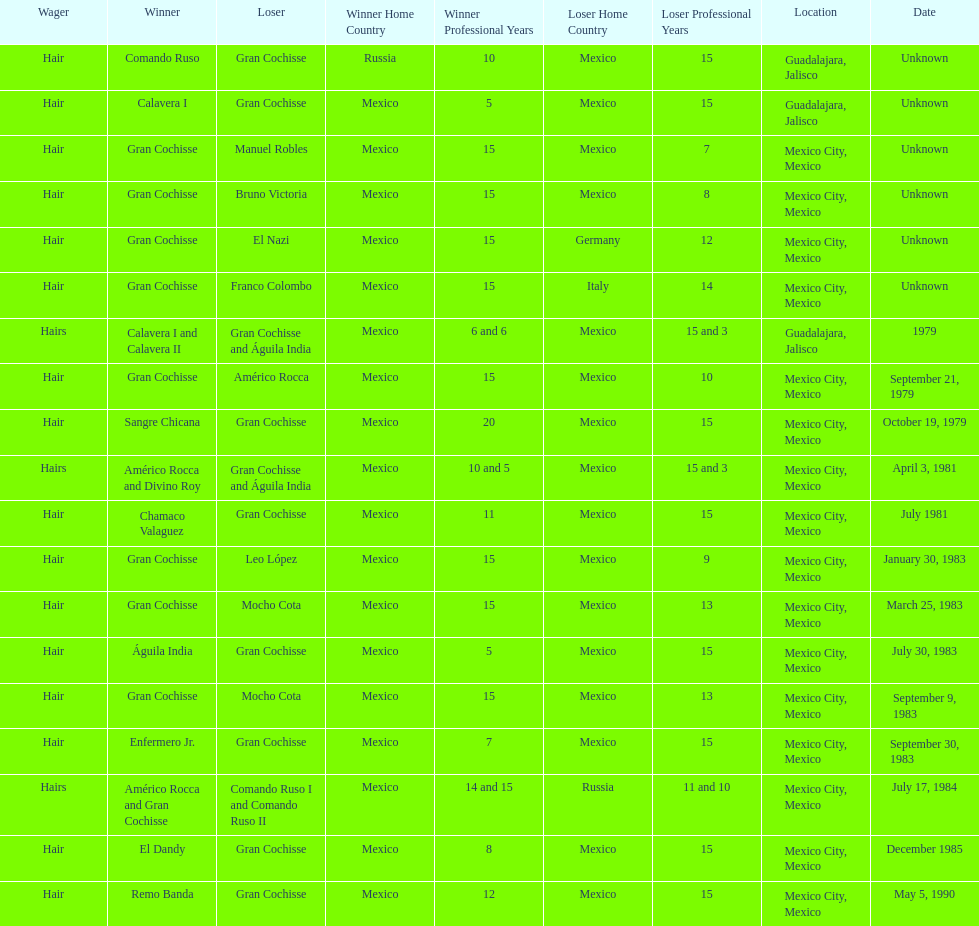How many winners were there before bruno victoria lost? 3. 